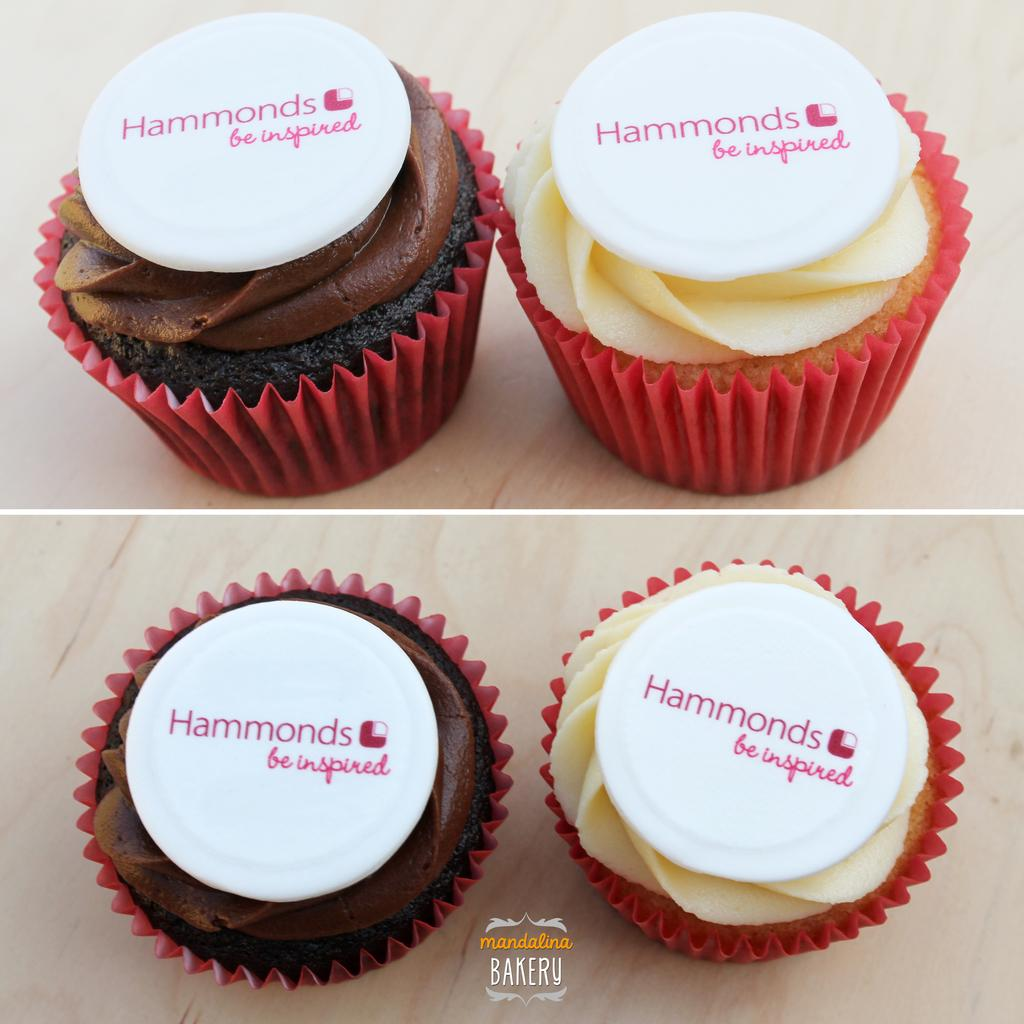What type of food is present in the image? The image contains cupcakes. What else can be seen in the image besides the cupcakes? There are white colored objects with text in the image. Can you describe the text at the bottom of the image? Yes, there is text at the bottom of the image. What rule is being enforced in space as depicted in the image? There is no depiction of space or any rules being enforced in the image; it contains cupcakes and text. 